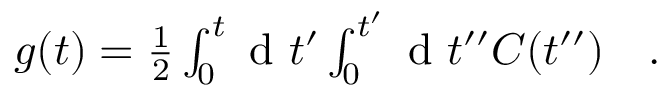<formula> <loc_0><loc_0><loc_500><loc_500>\begin{array} { r l } { g ( t ) = \frac { 1 } { 2 } \int _ { 0 } ^ { t } d t ^ { \prime } \int _ { 0 } ^ { t ^ { \prime } } d t ^ { \prime \prime } C ( t ^ { \prime \prime } ) } & . } \end{array}</formula> 